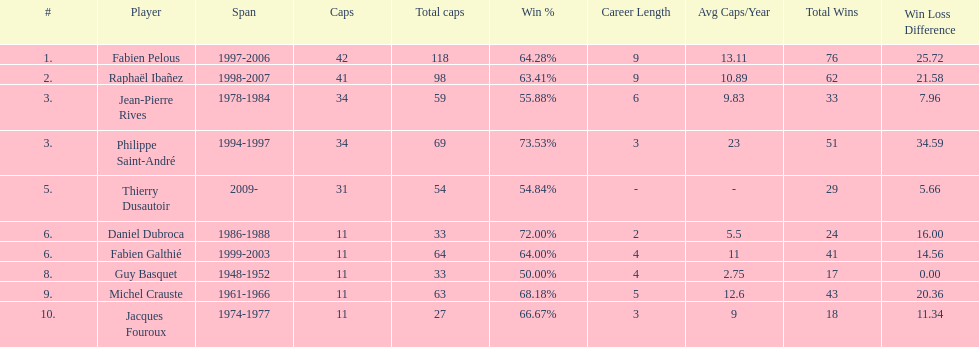What is the number of players with spans longer than three years? 6. 